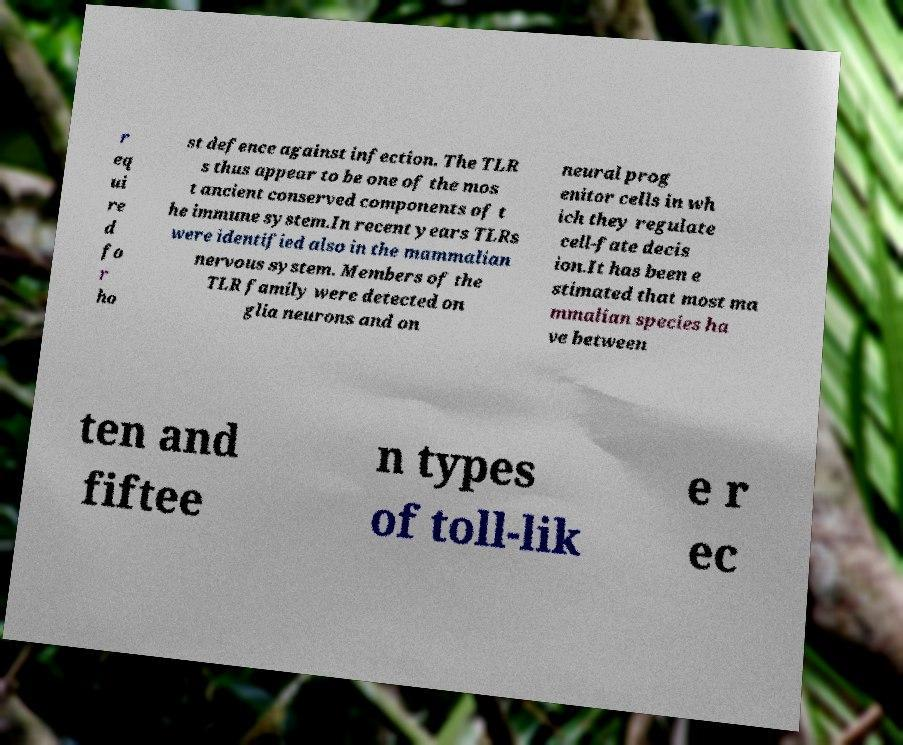Please read and relay the text visible in this image. What does it say? r eq ui re d fo r ho st defence against infection. The TLR s thus appear to be one of the mos t ancient conserved components of t he immune system.In recent years TLRs were identified also in the mammalian nervous system. Members of the TLR family were detected on glia neurons and on neural prog enitor cells in wh ich they regulate cell-fate decis ion.It has been e stimated that most ma mmalian species ha ve between ten and fiftee n types of toll-lik e r ec 